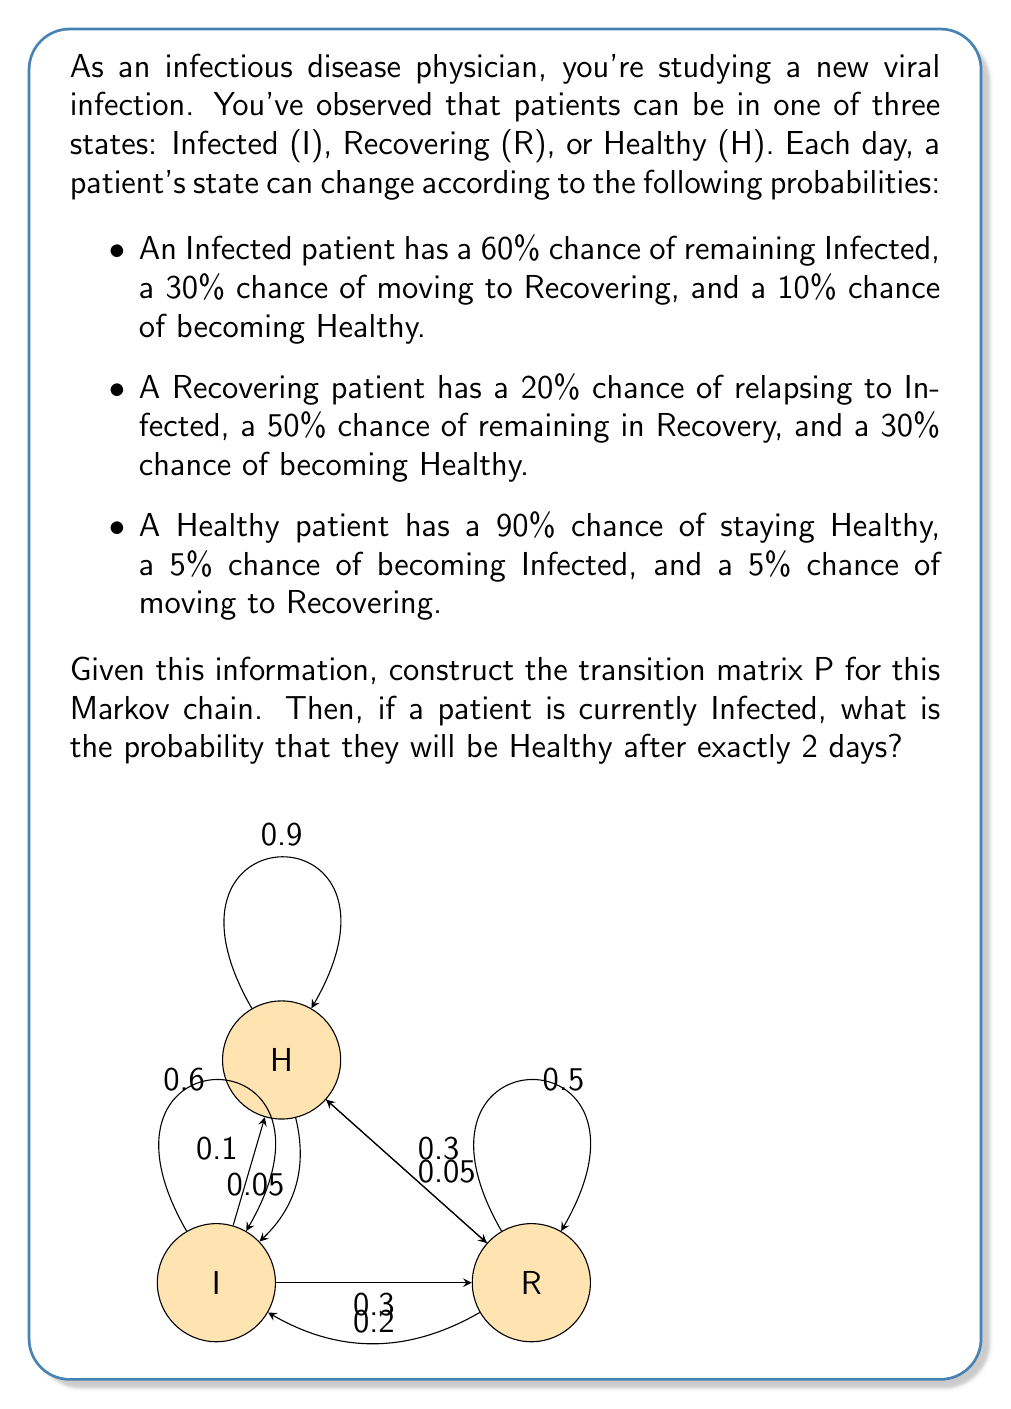Can you solve this math problem? Let's approach this step-by-step:

1) First, we need to construct the transition matrix P. The rows and columns of P represent the states in the order Infected (I), Recovering (R), and Healthy (H).

$$P = \begin{bmatrix}
0.6 & 0.3 & 0.1 \\
0.2 & 0.5 & 0.3 \\
0.05 & 0.05 & 0.9
\end{bmatrix}$$

2) To find the probability of being in a certain state after 2 days, we need to calculate $P^2$. We can do this by multiplying P by itself:

$$P^2 = \begin{bmatrix}
0.6 & 0.3 & 0.1 \\
0.2 & 0.5 & 0.3 \\
0.05 & 0.05 & 0.9
\end{bmatrix} \times \begin{bmatrix}
0.6 & 0.3 & 0.1 \\
0.2 & 0.5 & 0.3 \\
0.05 & 0.05 & 0.9
\end{bmatrix}$$

3) Performing the matrix multiplication:

$$P^2 = \begin{bmatrix}
0.41 & 0.33 & 0.26 \\
0.235 & 0.34 & 0.425 \\
0.0675 & 0.0825 & 0.85
\end{bmatrix}$$

4) The question asks for the probability of being Healthy after 2 days, given that the patient is currently Infected. This corresponds to the element in the first row (Infected) and third column (Healthy) of $P^2$.

5) From our calculated $P^2$, we can see that this probability is 0.26 or 26%.
Answer: 0.26 